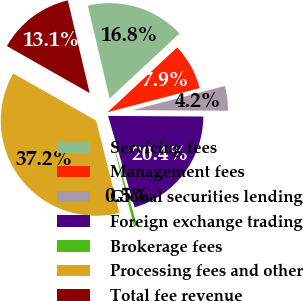<chart> <loc_0><loc_0><loc_500><loc_500><pie_chart><fcel>Servicing fees<fcel>Management fees<fcel>Global securities lending<fcel>Foreign exchange trading<fcel>Brokerage fees<fcel>Processing fees and other<fcel>Total fee revenue<nl><fcel>16.75%<fcel>7.85%<fcel>4.19%<fcel>20.42%<fcel>0.52%<fcel>37.17%<fcel>13.09%<nl></chart> 